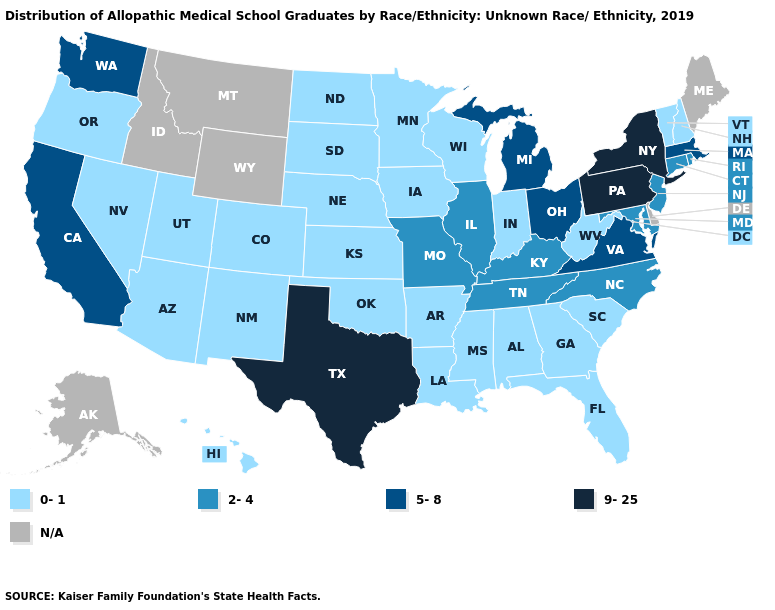What is the lowest value in the South?
Concise answer only. 0-1. Which states hav the highest value in the West?
Short answer required. California, Washington. What is the value of Indiana?
Write a very short answer. 0-1. What is the highest value in the USA?
Write a very short answer. 9-25. Name the states that have a value in the range 9-25?
Keep it brief. New York, Pennsylvania, Texas. What is the highest value in the MidWest ?
Give a very brief answer. 5-8. Name the states that have a value in the range 5-8?
Quick response, please. California, Massachusetts, Michigan, Ohio, Virginia, Washington. Name the states that have a value in the range 2-4?
Quick response, please. Connecticut, Illinois, Kentucky, Maryland, Missouri, New Jersey, North Carolina, Rhode Island, Tennessee. What is the lowest value in states that border Maryland?
Be succinct. 0-1. Name the states that have a value in the range 9-25?
Keep it brief. New York, Pennsylvania, Texas. Name the states that have a value in the range 2-4?
Write a very short answer. Connecticut, Illinois, Kentucky, Maryland, Missouri, New Jersey, North Carolina, Rhode Island, Tennessee. Name the states that have a value in the range 5-8?
Keep it brief. California, Massachusetts, Michigan, Ohio, Virginia, Washington. Which states have the highest value in the USA?
Answer briefly. New York, Pennsylvania, Texas. What is the value of Colorado?
Write a very short answer. 0-1. 